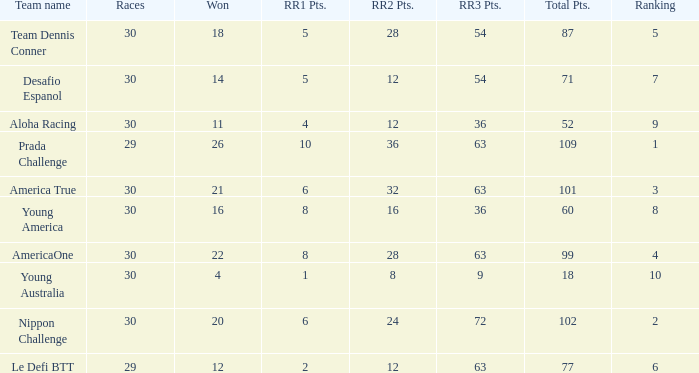Name the ranking for rr2 pts being 8 10.0. 